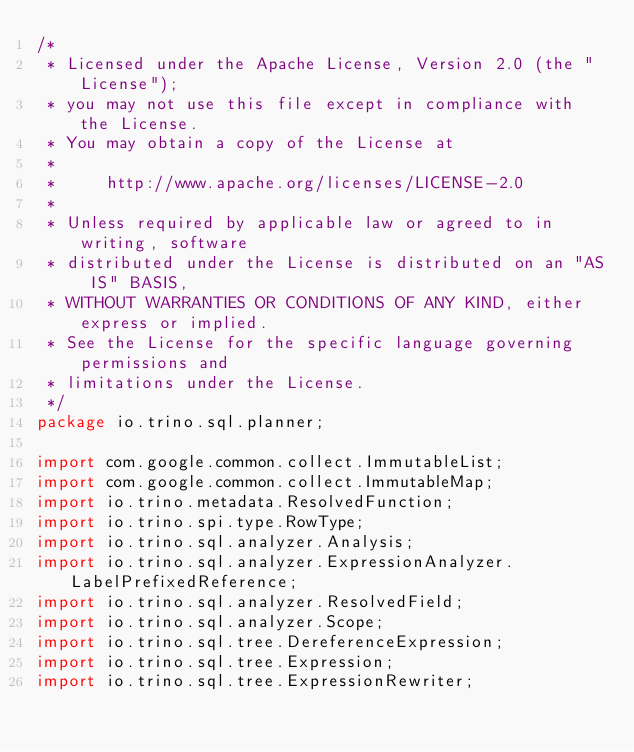Convert code to text. <code><loc_0><loc_0><loc_500><loc_500><_Java_>/*
 * Licensed under the Apache License, Version 2.0 (the "License");
 * you may not use this file except in compliance with the License.
 * You may obtain a copy of the License at
 *
 *     http://www.apache.org/licenses/LICENSE-2.0
 *
 * Unless required by applicable law or agreed to in writing, software
 * distributed under the License is distributed on an "AS IS" BASIS,
 * WITHOUT WARRANTIES OR CONDITIONS OF ANY KIND, either express or implied.
 * See the License for the specific language governing permissions and
 * limitations under the License.
 */
package io.trino.sql.planner;

import com.google.common.collect.ImmutableList;
import com.google.common.collect.ImmutableMap;
import io.trino.metadata.ResolvedFunction;
import io.trino.spi.type.RowType;
import io.trino.sql.analyzer.Analysis;
import io.trino.sql.analyzer.ExpressionAnalyzer.LabelPrefixedReference;
import io.trino.sql.analyzer.ResolvedField;
import io.trino.sql.analyzer.Scope;
import io.trino.sql.tree.DereferenceExpression;
import io.trino.sql.tree.Expression;
import io.trino.sql.tree.ExpressionRewriter;</code> 